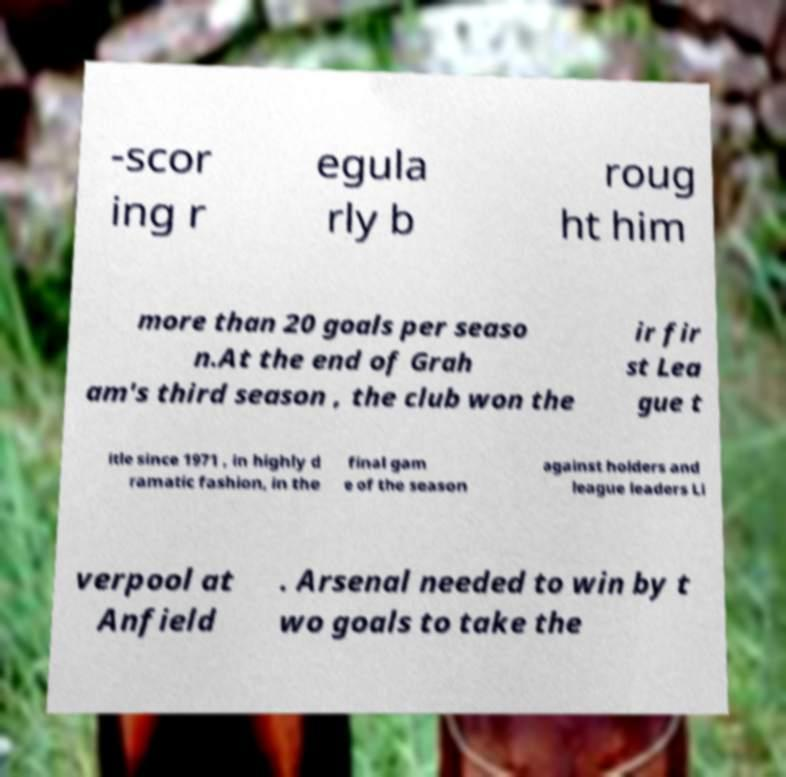Can you accurately transcribe the text from the provided image for me? -scor ing r egula rly b roug ht him more than 20 goals per seaso n.At the end of Grah am's third season , the club won the ir fir st Lea gue t itle since 1971 , in highly d ramatic fashion, in the final gam e of the season against holders and league leaders Li verpool at Anfield . Arsenal needed to win by t wo goals to take the 